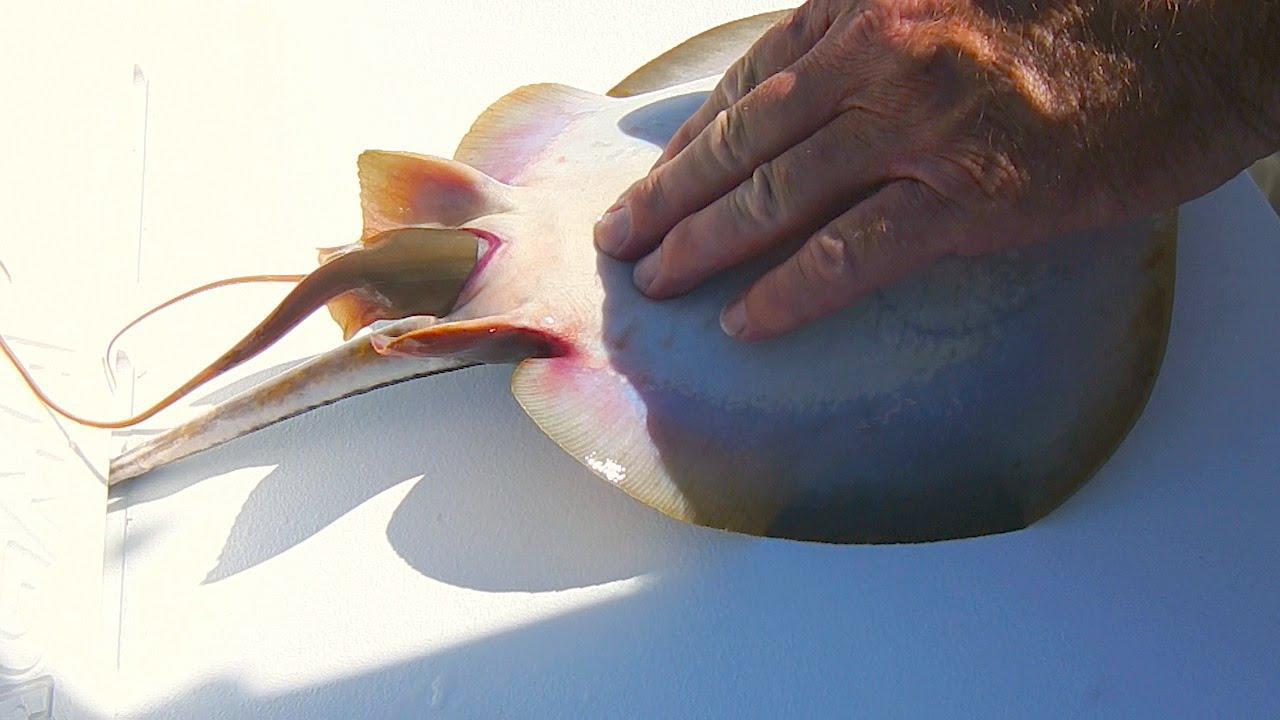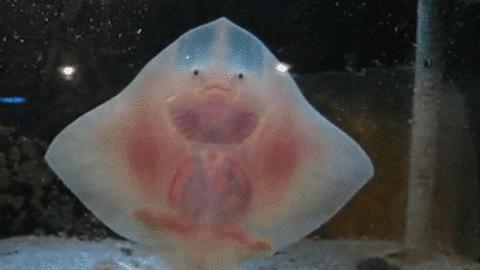The first image is the image on the left, the second image is the image on the right. Considering the images on both sides, is "All of the stingrays are shown upright with undersides facing the camera and 'wings' outspread." valid? Answer yes or no. No. The first image is the image on the left, the second image is the image on the right. Assess this claim about the two images: "A single ray presses its body against the glass in each of the images.". Correct or not? Answer yes or no. No. 